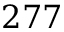Convert formula to latex. <formula><loc_0><loc_0><loc_500><loc_500>2 7 7</formula> 